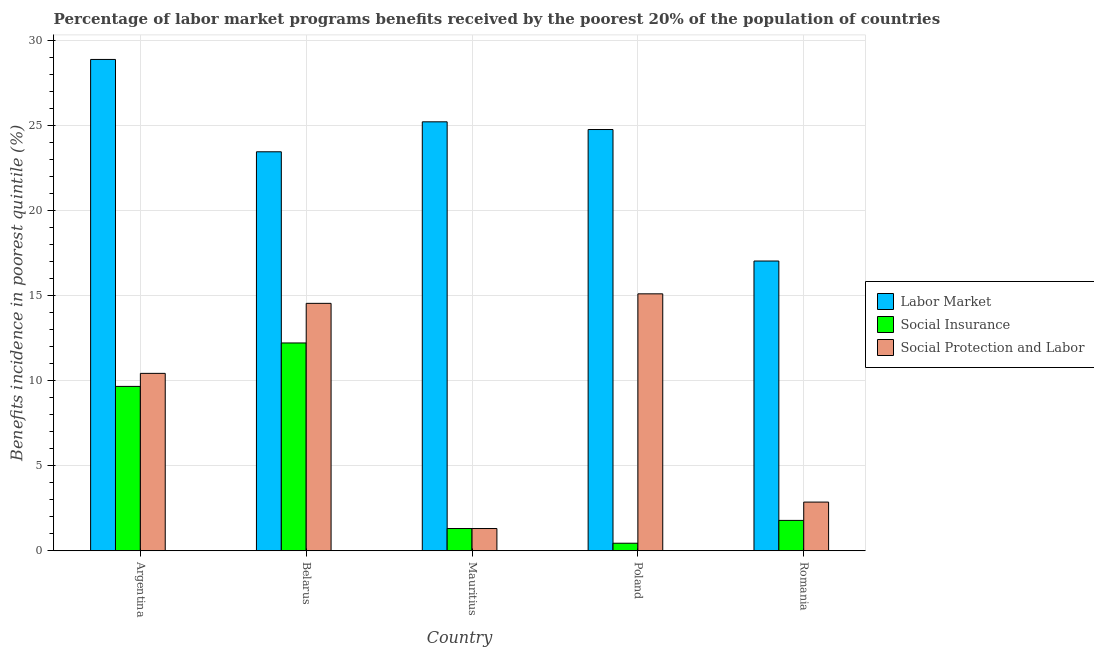How many groups of bars are there?
Give a very brief answer. 5. Are the number of bars per tick equal to the number of legend labels?
Make the answer very short. Yes. Are the number of bars on each tick of the X-axis equal?
Keep it short and to the point. Yes. What is the percentage of benefits received due to labor market programs in Belarus?
Offer a terse response. 23.45. Across all countries, what is the maximum percentage of benefits received due to labor market programs?
Offer a terse response. 28.88. Across all countries, what is the minimum percentage of benefits received due to social protection programs?
Your answer should be very brief. 1.31. In which country was the percentage of benefits received due to labor market programs maximum?
Your answer should be compact. Argentina. In which country was the percentage of benefits received due to labor market programs minimum?
Provide a short and direct response. Romania. What is the total percentage of benefits received due to social protection programs in the graph?
Your response must be concise. 44.25. What is the difference between the percentage of benefits received due to social insurance programs in Mauritius and that in Poland?
Your answer should be compact. 0.86. What is the difference between the percentage of benefits received due to social protection programs in Argentina and the percentage of benefits received due to social insurance programs in Mauritius?
Give a very brief answer. 9.12. What is the average percentage of benefits received due to social protection programs per country?
Offer a very short reply. 8.85. What is the difference between the percentage of benefits received due to social insurance programs and percentage of benefits received due to social protection programs in Argentina?
Provide a short and direct response. -0.77. In how many countries, is the percentage of benefits received due to labor market programs greater than 11 %?
Give a very brief answer. 5. What is the ratio of the percentage of benefits received due to social protection programs in Argentina to that in Belarus?
Keep it short and to the point. 0.72. Is the percentage of benefits received due to social insurance programs in Belarus less than that in Mauritius?
Give a very brief answer. No. Is the difference between the percentage of benefits received due to labor market programs in Argentina and Mauritius greater than the difference between the percentage of benefits received due to social protection programs in Argentina and Mauritius?
Keep it short and to the point. No. What is the difference between the highest and the second highest percentage of benefits received due to social protection programs?
Keep it short and to the point. 0.56. What is the difference between the highest and the lowest percentage of benefits received due to social insurance programs?
Make the answer very short. 11.77. What does the 2nd bar from the left in Argentina represents?
Ensure brevity in your answer.  Social Insurance. What does the 2nd bar from the right in Romania represents?
Offer a very short reply. Social Insurance. Is it the case that in every country, the sum of the percentage of benefits received due to labor market programs and percentage of benefits received due to social insurance programs is greater than the percentage of benefits received due to social protection programs?
Your response must be concise. Yes. Does the graph contain any zero values?
Give a very brief answer. No. Where does the legend appear in the graph?
Offer a very short reply. Center right. How many legend labels are there?
Your response must be concise. 3. What is the title of the graph?
Offer a terse response. Percentage of labor market programs benefits received by the poorest 20% of the population of countries. What is the label or title of the Y-axis?
Your answer should be compact. Benefits incidence in poorest quintile (%). What is the Benefits incidence in poorest quintile (%) of Labor Market in Argentina?
Offer a very short reply. 28.88. What is the Benefits incidence in poorest quintile (%) of Social Insurance in Argentina?
Keep it short and to the point. 9.66. What is the Benefits incidence in poorest quintile (%) of Social Protection and Labor in Argentina?
Your answer should be very brief. 10.43. What is the Benefits incidence in poorest quintile (%) in Labor Market in Belarus?
Keep it short and to the point. 23.45. What is the Benefits incidence in poorest quintile (%) in Social Insurance in Belarus?
Make the answer very short. 12.22. What is the Benefits incidence in poorest quintile (%) in Social Protection and Labor in Belarus?
Keep it short and to the point. 14.54. What is the Benefits incidence in poorest quintile (%) in Labor Market in Mauritius?
Your response must be concise. 25.22. What is the Benefits incidence in poorest quintile (%) in Social Insurance in Mauritius?
Your response must be concise. 1.31. What is the Benefits incidence in poorest quintile (%) of Social Protection and Labor in Mauritius?
Keep it short and to the point. 1.31. What is the Benefits incidence in poorest quintile (%) of Labor Market in Poland?
Ensure brevity in your answer.  24.76. What is the Benefits incidence in poorest quintile (%) in Social Insurance in Poland?
Offer a very short reply. 0.44. What is the Benefits incidence in poorest quintile (%) of Social Protection and Labor in Poland?
Your response must be concise. 15.1. What is the Benefits incidence in poorest quintile (%) in Labor Market in Romania?
Offer a terse response. 17.03. What is the Benefits incidence in poorest quintile (%) of Social Insurance in Romania?
Provide a succinct answer. 1.79. What is the Benefits incidence in poorest quintile (%) of Social Protection and Labor in Romania?
Make the answer very short. 2.86. Across all countries, what is the maximum Benefits incidence in poorest quintile (%) in Labor Market?
Provide a succinct answer. 28.88. Across all countries, what is the maximum Benefits incidence in poorest quintile (%) in Social Insurance?
Keep it short and to the point. 12.22. Across all countries, what is the maximum Benefits incidence in poorest quintile (%) in Social Protection and Labor?
Your response must be concise. 15.1. Across all countries, what is the minimum Benefits incidence in poorest quintile (%) in Labor Market?
Your answer should be very brief. 17.03. Across all countries, what is the minimum Benefits incidence in poorest quintile (%) in Social Insurance?
Your answer should be compact. 0.44. Across all countries, what is the minimum Benefits incidence in poorest quintile (%) of Social Protection and Labor?
Ensure brevity in your answer.  1.31. What is the total Benefits incidence in poorest quintile (%) in Labor Market in the graph?
Provide a short and direct response. 119.35. What is the total Benefits incidence in poorest quintile (%) of Social Insurance in the graph?
Offer a very short reply. 25.42. What is the total Benefits incidence in poorest quintile (%) of Social Protection and Labor in the graph?
Offer a very short reply. 44.25. What is the difference between the Benefits incidence in poorest quintile (%) in Labor Market in Argentina and that in Belarus?
Offer a very short reply. 5.43. What is the difference between the Benefits incidence in poorest quintile (%) of Social Insurance in Argentina and that in Belarus?
Offer a very short reply. -2.55. What is the difference between the Benefits incidence in poorest quintile (%) of Social Protection and Labor in Argentina and that in Belarus?
Keep it short and to the point. -4.12. What is the difference between the Benefits incidence in poorest quintile (%) in Labor Market in Argentina and that in Mauritius?
Ensure brevity in your answer.  3.67. What is the difference between the Benefits incidence in poorest quintile (%) of Social Insurance in Argentina and that in Mauritius?
Offer a terse response. 8.36. What is the difference between the Benefits incidence in poorest quintile (%) of Social Protection and Labor in Argentina and that in Mauritius?
Provide a short and direct response. 9.12. What is the difference between the Benefits incidence in poorest quintile (%) of Labor Market in Argentina and that in Poland?
Provide a succinct answer. 4.12. What is the difference between the Benefits incidence in poorest quintile (%) of Social Insurance in Argentina and that in Poland?
Give a very brief answer. 9.22. What is the difference between the Benefits incidence in poorest quintile (%) of Social Protection and Labor in Argentina and that in Poland?
Offer a terse response. -4.68. What is the difference between the Benefits incidence in poorest quintile (%) in Labor Market in Argentina and that in Romania?
Provide a short and direct response. 11.85. What is the difference between the Benefits incidence in poorest quintile (%) of Social Insurance in Argentina and that in Romania?
Keep it short and to the point. 7.88. What is the difference between the Benefits incidence in poorest quintile (%) of Social Protection and Labor in Argentina and that in Romania?
Provide a succinct answer. 7.57. What is the difference between the Benefits incidence in poorest quintile (%) of Labor Market in Belarus and that in Mauritius?
Provide a succinct answer. -1.76. What is the difference between the Benefits incidence in poorest quintile (%) in Social Insurance in Belarus and that in Mauritius?
Provide a short and direct response. 10.91. What is the difference between the Benefits incidence in poorest quintile (%) in Social Protection and Labor in Belarus and that in Mauritius?
Your answer should be compact. 13.24. What is the difference between the Benefits incidence in poorest quintile (%) in Labor Market in Belarus and that in Poland?
Make the answer very short. -1.31. What is the difference between the Benefits incidence in poorest quintile (%) in Social Insurance in Belarus and that in Poland?
Keep it short and to the point. 11.77. What is the difference between the Benefits incidence in poorest quintile (%) of Social Protection and Labor in Belarus and that in Poland?
Your response must be concise. -0.56. What is the difference between the Benefits incidence in poorest quintile (%) in Labor Market in Belarus and that in Romania?
Give a very brief answer. 6.42. What is the difference between the Benefits incidence in poorest quintile (%) of Social Insurance in Belarus and that in Romania?
Offer a very short reply. 10.43. What is the difference between the Benefits incidence in poorest quintile (%) of Social Protection and Labor in Belarus and that in Romania?
Your response must be concise. 11.68. What is the difference between the Benefits incidence in poorest quintile (%) of Labor Market in Mauritius and that in Poland?
Your response must be concise. 0.45. What is the difference between the Benefits incidence in poorest quintile (%) in Social Insurance in Mauritius and that in Poland?
Your response must be concise. 0.86. What is the difference between the Benefits incidence in poorest quintile (%) of Social Protection and Labor in Mauritius and that in Poland?
Your answer should be very brief. -13.8. What is the difference between the Benefits incidence in poorest quintile (%) in Labor Market in Mauritius and that in Romania?
Your answer should be compact. 8.18. What is the difference between the Benefits incidence in poorest quintile (%) of Social Insurance in Mauritius and that in Romania?
Give a very brief answer. -0.48. What is the difference between the Benefits incidence in poorest quintile (%) of Social Protection and Labor in Mauritius and that in Romania?
Make the answer very short. -1.55. What is the difference between the Benefits incidence in poorest quintile (%) of Labor Market in Poland and that in Romania?
Give a very brief answer. 7.73. What is the difference between the Benefits incidence in poorest quintile (%) of Social Insurance in Poland and that in Romania?
Your response must be concise. -1.34. What is the difference between the Benefits incidence in poorest quintile (%) in Social Protection and Labor in Poland and that in Romania?
Offer a terse response. 12.24. What is the difference between the Benefits incidence in poorest quintile (%) in Labor Market in Argentina and the Benefits incidence in poorest quintile (%) in Social Insurance in Belarus?
Give a very brief answer. 16.67. What is the difference between the Benefits incidence in poorest quintile (%) of Labor Market in Argentina and the Benefits incidence in poorest quintile (%) of Social Protection and Labor in Belarus?
Provide a short and direct response. 14.34. What is the difference between the Benefits incidence in poorest quintile (%) of Social Insurance in Argentina and the Benefits incidence in poorest quintile (%) of Social Protection and Labor in Belarus?
Your response must be concise. -4.88. What is the difference between the Benefits incidence in poorest quintile (%) in Labor Market in Argentina and the Benefits incidence in poorest quintile (%) in Social Insurance in Mauritius?
Keep it short and to the point. 27.58. What is the difference between the Benefits incidence in poorest quintile (%) in Labor Market in Argentina and the Benefits incidence in poorest quintile (%) in Social Protection and Labor in Mauritius?
Offer a very short reply. 27.58. What is the difference between the Benefits incidence in poorest quintile (%) of Social Insurance in Argentina and the Benefits incidence in poorest quintile (%) of Social Protection and Labor in Mauritius?
Make the answer very short. 8.36. What is the difference between the Benefits incidence in poorest quintile (%) of Labor Market in Argentina and the Benefits incidence in poorest quintile (%) of Social Insurance in Poland?
Offer a terse response. 28.44. What is the difference between the Benefits incidence in poorest quintile (%) in Labor Market in Argentina and the Benefits incidence in poorest quintile (%) in Social Protection and Labor in Poland?
Provide a short and direct response. 13.78. What is the difference between the Benefits incidence in poorest quintile (%) of Social Insurance in Argentina and the Benefits incidence in poorest quintile (%) of Social Protection and Labor in Poland?
Ensure brevity in your answer.  -5.44. What is the difference between the Benefits incidence in poorest quintile (%) of Labor Market in Argentina and the Benefits incidence in poorest quintile (%) of Social Insurance in Romania?
Your answer should be very brief. 27.1. What is the difference between the Benefits incidence in poorest quintile (%) of Labor Market in Argentina and the Benefits incidence in poorest quintile (%) of Social Protection and Labor in Romania?
Keep it short and to the point. 26.02. What is the difference between the Benefits incidence in poorest quintile (%) of Social Insurance in Argentina and the Benefits incidence in poorest quintile (%) of Social Protection and Labor in Romania?
Keep it short and to the point. 6.8. What is the difference between the Benefits incidence in poorest quintile (%) in Labor Market in Belarus and the Benefits incidence in poorest quintile (%) in Social Insurance in Mauritius?
Make the answer very short. 22.15. What is the difference between the Benefits incidence in poorest quintile (%) in Labor Market in Belarus and the Benefits incidence in poorest quintile (%) in Social Protection and Labor in Mauritius?
Ensure brevity in your answer.  22.15. What is the difference between the Benefits incidence in poorest quintile (%) in Social Insurance in Belarus and the Benefits incidence in poorest quintile (%) in Social Protection and Labor in Mauritius?
Your response must be concise. 10.91. What is the difference between the Benefits incidence in poorest quintile (%) of Labor Market in Belarus and the Benefits incidence in poorest quintile (%) of Social Insurance in Poland?
Keep it short and to the point. 23.01. What is the difference between the Benefits incidence in poorest quintile (%) in Labor Market in Belarus and the Benefits incidence in poorest quintile (%) in Social Protection and Labor in Poland?
Offer a terse response. 8.35. What is the difference between the Benefits incidence in poorest quintile (%) of Social Insurance in Belarus and the Benefits incidence in poorest quintile (%) of Social Protection and Labor in Poland?
Your answer should be compact. -2.89. What is the difference between the Benefits incidence in poorest quintile (%) of Labor Market in Belarus and the Benefits incidence in poorest quintile (%) of Social Insurance in Romania?
Offer a very short reply. 21.67. What is the difference between the Benefits incidence in poorest quintile (%) in Labor Market in Belarus and the Benefits incidence in poorest quintile (%) in Social Protection and Labor in Romania?
Provide a succinct answer. 20.59. What is the difference between the Benefits incidence in poorest quintile (%) in Social Insurance in Belarus and the Benefits incidence in poorest quintile (%) in Social Protection and Labor in Romania?
Your answer should be very brief. 9.36. What is the difference between the Benefits incidence in poorest quintile (%) of Labor Market in Mauritius and the Benefits incidence in poorest quintile (%) of Social Insurance in Poland?
Your answer should be very brief. 24.77. What is the difference between the Benefits incidence in poorest quintile (%) in Labor Market in Mauritius and the Benefits incidence in poorest quintile (%) in Social Protection and Labor in Poland?
Provide a short and direct response. 10.11. What is the difference between the Benefits incidence in poorest quintile (%) of Social Insurance in Mauritius and the Benefits incidence in poorest quintile (%) of Social Protection and Labor in Poland?
Keep it short and to the point. -13.8. What is the difference between the Benefits incidence in poorest quintile (%) of Labor Market in Mauritius and the Benefits incidence in poorest quintile (%) of Social Insurance in Romania?
Make the answer very short. 23.43. What is the difference between the Benefits incidence in poorest quintile (%) of Labor Market in Mauritius and the Benefits incidence in poorest quintile (%) of Social Protection and Labor in Romania?
Your answer should be very brief. 22.35. What is the difference between the Benefits incidence in poorest quintile (%) in Social Insurance in Mauritius and the Benefits incidence in poorest quintile (%) in Social Protection and Labor in Romania?
Your answer should be very brief. -1.55. What is the difference between the Benefits incidence in poorest quintile (%) in Labor Market in Poland and the Benefits incidence in poorest quintile (%) in Social Insurance in Romania?
Offer a terse response. 22.98. What is the difference between the Benefits incidence in poorest quintile (%) of Labor Market in Poland and the Benefits incidence in poorest quintile (%) of Social Protection and Labor in Romania?
Your answer should be very brief. 21.9. What is the difference between the Benefits incidence in poorest quintile (%) in Social Insurance in Poland and the Benefits incidence in poorest quintile (%) in Social Protection and Labor in Romania?
Provide a succinct answer. -2.42. What is the average Benefits incidence in poorest quintile (%) in Labor Market per country?
Keep it short and to the point. 23.87. What is the average Benefits incidence in poorest quintile (%) in Social Insurance per country?
Your answer should be very brief. 5.08. What is the average Benefits incidence in poorest quintile (%) in Social Protection and Labor per country?
Provide a succinct answer. 8.85. What is the difference between the Benefits incidence in poorest quintile (%) in Labor Market and Benefits incidence in poorest quintile (%) in Social Insurance in Argentina?
Your answer should be very brief. 19.22. What is the difference between the Benefits incidence in poorest quintile (%) of Labor Market and Benefits incidence in poorest quintile (%) of Social Protection and Labor in Argentina?
Your answer should be very brief. 18.45. What is the difference between the Benefits incidence in poorest quintile (%) in Social Insurance and Benefits incidence in poorest quintile (%) in Social Protection and Labor in Argentina?
Ensure brevity in your answer.  -0.77. What is the difference between the Benefits incidence in poorest quintile (%) in Labor Market and Benefits incidence in poorest quintile (%) in Social Insurance in Belarus?
Provide a short and direct response. 11.24. What is the difference between the Benefits incidence in poorest quintile (%) in Labor Market and Benefits incidence in poorest quintile (%) in Social Protection and Labor in Belarus?
Give a very brief answer. 8.91. What is the difference between the Benefits incidence in poorest quintile (%) in Social Insurance and Benefits incidence in poorest quintile (%) in Social Protection and Labor in Belarus?
Give a very brief answer. -2.33. What is the difference between the Benefits incidence in poorest quintile (%) of Labor Market and Benefits incidence in poorest quintile (%) of Social Insurance in Mauritius?
Make the answer very short. 23.91. What is the difference between the Benefits incidence in poorest quintile (%) in Labor Market and Benefits incidence in poorest quintile (%) in Social Protection and Labor in Mauritius?
Provide a succinct answer. 23.91. What is the difference between the Benefits incidence in poorest quintile (%) of Labor Market and Benefits incidence in poorest quintile (%) of Social Insurance in Poland?
Your response must be concise. 24.32. What is the difference between the Benefits incidence in poorest quintile (%) in Labor Market and Benefits incidence in poorest quintile (%) in Social Protection and Labor in Poland?
Make the answer very short. 9.66. What is the difference between the Benefits incidence in poorest quintile (%) of Social Insurance and Benefits incidence in poorest quintile (%) of Social Protection and Labor in Poland?
Provide a succinct answer. -14.66. What is the difference between the Benefits incidence in poorest quintile (%) in Labor Market and Benefits incidence in poorest quintile (%) in Social Insurance in Romania?
Provide a short and direct response. 15.25. What is the difference between the Benefits incidence in poorest quintile (%) in Labor Market and Benefits incidence in poorest quintile (%) in Social Protection and Labor in Romania?
Offer a terse response. 14.17. What is the difference between the Benefits incidence in poorest quintile (%) of Social Insurance and Benefits incidence in poorest quintile (%) of Social Protection and Labor in Romania?
Ensure brevity in your answer.  -1.08. What is the ratio of the Benefits incidence in poorest quintile (%) of Labor Market in Argentina to that in Belarus?
Make the answer very short. 1.23. What is the ratio of the Benefits incidence in poorest quintile (%) of Social Insurance in Argentina to that in Belarus?
Give a very brief answer. 0.79. What is the ratio of the Benefits incidence in poorest quintile (%) in Social Protection and Labor in Argentina to that in Belarus?
Your answer should be very brief. 0.72. What is the ratio of the Benefits incidence in poorest quintile (%) in Labor Market in Argentina to that in Mauritius?
Make the answer very short. 1.15. What is the ratio of the Benefits incidence in poorest quintile (%) of Social Insurance in Argentina to that in Mauritius?
Your answer should be very brief. 7.39. What is the ratio of the Benefits incidence in poorest quintile (%) of Social Protection and Labor in Argentina to that in Mauritius?
Provide a short and direct response. 7.97. What is the ratio of the Benefits incidence in poorest quintile (%) of Labor Market in Argentina to that in Poland?
Make the answer very short. 1.17. What is the ratio of the Benefits incidence in poorest quintile (%) in Social Insurance in Argentina to that in Poland?
Your answer should be compact. 21.76. What is the ratio of the Benefits incidence in poorest quintile (%) in Social Protection and Labor in Argentina to that in Poland?
Ensure brevity in your answer.  0.69. What is the ratio of the Benefits incidence in poorest quintile (%) in Labor Market in Argentina to that in Romania?
Make the answer very short. 1.7. What is the ratio of the Benefits incidence in poorest quintile (%) in Social Insurance in Argentina to that in Romania?
Your response must be concise. 5.41. What is the ratio of the Benefits incidence in poorest quintile (%) of Social Protection and Labor in Argentina to that in Romania?
Ensure brevity in your answer.  3.64. What is the ratio of the Benefits incidence in poorest quintile (%) in Labor Market in Belarus to that in Mauritius?
Provide a short and direct response. 0.93. What is the ratio of the Benefits incidence in poorest quintile (%) in Social Insurance in Belarus to that in Mauritius?
Your response must be concise. 9.34. What is the ratio of the Benefits incidence in poorest quintile (%) in Social Protection and Labor in Belarus to that in Mauritius?
Ensure brevity in your answer.  11.12. What is the ratio of the Benefits incidence in poorest quintile (%) in Labor Market in Belarus to that in Poland?
Keep it short and to the point. 0.95. What is the ratio of the Benefits incidence in poorest quintile (%) in Social Insurance in Belarus to that in Poland?
Your answer should be compact. 27.51. What is the ratio of the Benefits incidence in poorest quintile (%) in Social Protection and Labor in Belarus to that in Poland?
Keep it short and to the point. 0.96. What is the ratio of the Benefits incidence in poorest quintile (%) in Labor Market in Belarus to that in Romania?
Your response must be concise. 1.38. What is the ratio of the Benefits incidence in poorest quintile (%) in Social Insurance in Belarus to that in Romania?
Your answer should be compact. 6.84. What is the ratio of the Benefits incidence in poorest quintile (%) of Social Protection and Labor in Belarus to that in Romania?
Provide a short and direct response. 5.08. What is the ratio of the Benefits incidence in poorest quintile (%) in Labor Market in Mauritius to that in Poland?
Keep it short and to the point. 1.02. What is the ratio of the Benefits incidence in poorest quintile (%) of Social Insurance in Mauritius to that in Poland?
Give a very brief answer. 2.95. What is the ratio of the Benefits incidence in poorest quintile (%) in Social Protection and Labor in Mauritius to that in Poland?
Give a very brief answer. 0.09. What is the ratio of the Benefits incidence in poorest quintile (%) in Labor Market in Mauritius to that in Romania?
Give a very brief answer. 1.48. What is the ratio of the Benefits incidence in poorest quintile (%) of Social Insurance in Mauritius to that in Romania?
Give a very brief answer. 0.73. What is the ratio of the Benefits incidence in poorest quintile (%) of Social Protection and Labor in Mauritius to that in Romania?
Offer a terse response. 0.46. What is the ratio of the Benefits incidence in poorest quintile (%) of Labor Market in Poland to that in Romania?
Keep it short and to the point. 1.45. What is the ratio of the Benefits incidence in poorest quintile (%) of Social Insurance in Poland to that in Romania?
Your answer should be very brief. 0.25. What is the ratio of the Benefits incidence in poorest quintile (%) in Social Protection and Labor in Poland to that in Romania?
Your response must be concise. 5.28. What is the difference between the highest and the second highest Benefits incidence in poorest quintile (%) in Labor Market?
Offer a terse response. 3.67. What is the difference between the highest and the second highest Benefits incidence in poorest quintile (%) of Social Insurance?
Offer a very short reply. 2.55. What is the difference between the highest and the second highest Benefits incidence in poorest quintile (%) of Social Protection and Labor?
Make the answer very short. 0.56. What is the difference between the highest and the lowest Benefits incidence in poorest quintile (%) in Labor Market?
Your response must be concise. 11.85. What is the difference between the highest and the lowest Benefits incidence in poorest quintile (%) in Social Insurance?
Offer a terse response. 11.77. What is the difference between the highest and the lowest Benefits incidence in poorest quintile (%) in Social Protection and Labor?
Offer a terse response. 13.8. 